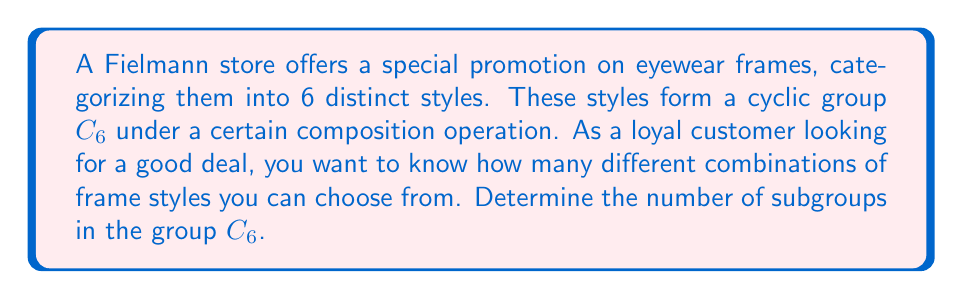Could you help me with this problem? To solve this problem, we need to follow these steps:

1) First, recall that $C_6$ is a cyclic group of order 6. Let's denote its generator as $a$, so $C_6 = \langle a \rangle = \{e, a, a^2, a^3, a^4, a^5\}$.

2) The subgroups of a cyclic group are precisely the cyclic subgroups generated by its elements. 

3) The order of a subgroup must divide the order of the group. The divisors of 6 are 1, 2, 3, and 6.

4) For each divisor $d$ of 6, there is a unique subgroup of order $d$. Let's find these subgroups:

   - Order 1: $\{e\}$ (the trivial subgroup)
   - Order 2: $\langle a^3 \rangle = \{e, a^3\}$
   - Order 3: $\langle a^2 \rangle = \{e, a^2, a^4\}$
   - Order 6: $\langle a \rangle = C_6$ itself

5) Count the number of subgroups we found: there are 4 subgroups in total.

This means that as a loyal Fielmann customer, you have 4 different combinations of frame styles to choose from under this special promotion, ranging from a single style (the trivial subgroup) to all 6 styles (the entire group).
Answer: The number of subgroups in $C_6$ is 4. 